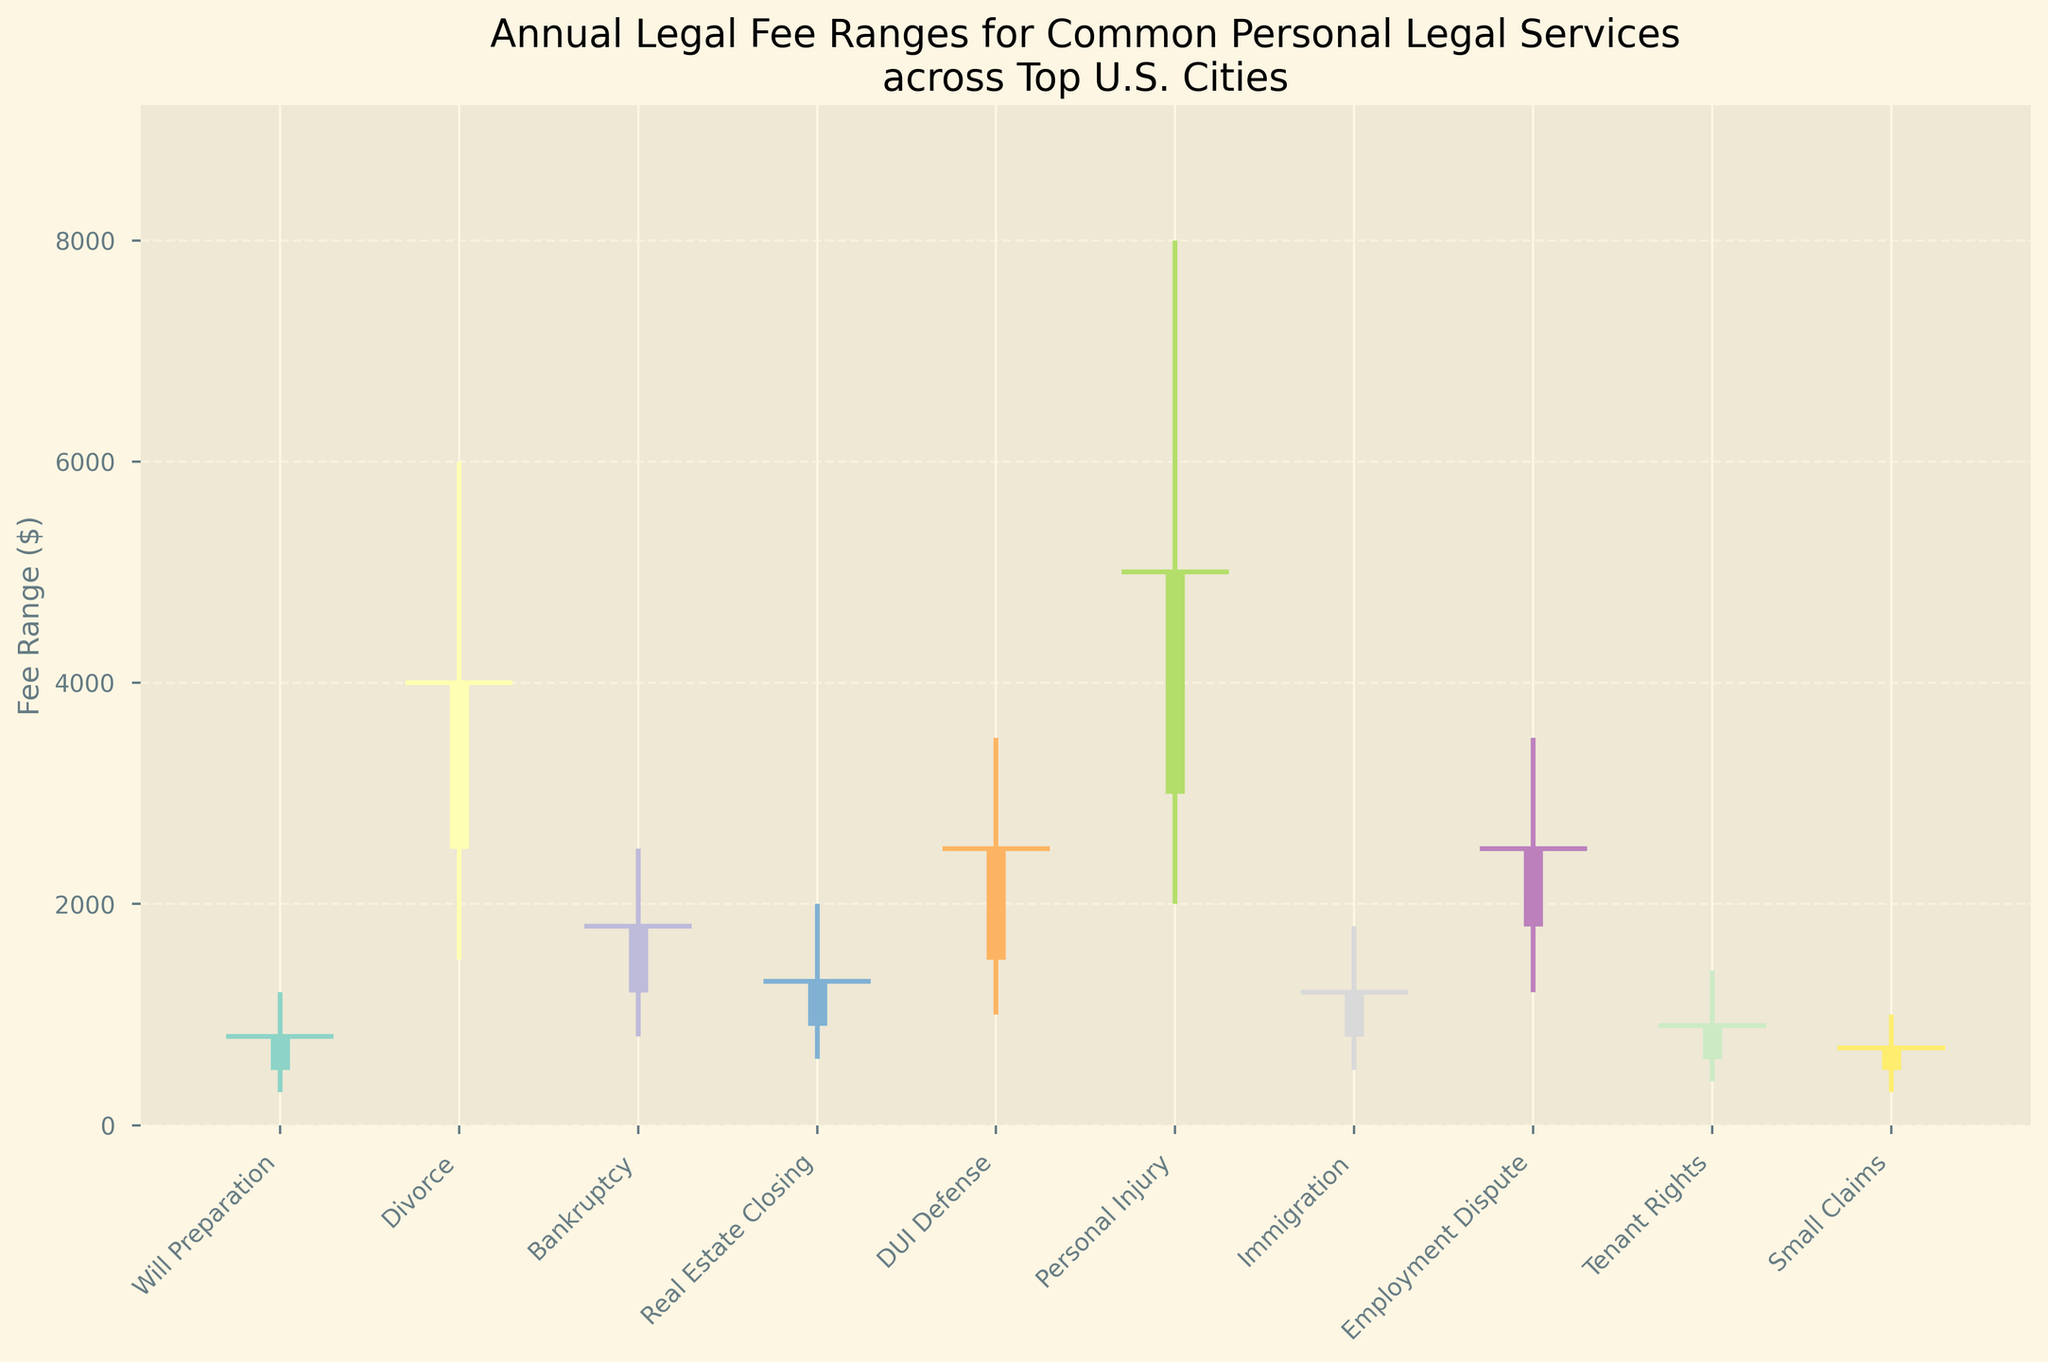What is the title of the chart? The title of the chart is displayed at the top and summarizes what the chart is about
Answer: Annual Legal Fee Ranges for Common Personal Legal Services across Top U.S. Cities Which city has the highest maximum fee for Personal Injury services? By looking at the high values, the highest maximum fee for Personal Injury services is highlighted
Answer: San Francisco What is the fee range for Will Preparation services in New York? The fee range is the difference between the high and low values for Will Preparation services in New York
Answer: $300 to $1200 How does the fee for DUI Defense in Houston compare to Divorce in Los Angeles at the low end? Compare the low values for DUI Defense and Divorce services in the respective cities
Answer: DUI Defense: $1000, Divorce: $1500, so Divorce in Los Angeles is higher Which legal service has the smallest difference between its opening and closing fees in Boston? Calculate the difference between the opening and closing fees for each service in Boston
Answer: Immigration, with fees from $800 to $1200 What is the average fee for Real Estate Closing services in Miami? Average fee can be calculated by (low + high) / 2
Answer: (600 + 2000)/2 = $1300 Which city has the widest fee range for Employment Dispute services? Look for the service "Employment Dispute" and find the city with the largest difference between high and low fees
Answer: Seattle What is the highest closing fee among all the services and cities? Look through the close values to identify the highest
Answer: $5000 for Personal Injury in San Francisco Which service in Denver has its opening fee closer to its high fee than to its low fee? Compare the placement of the opening fee relative to its low and high for services in Denver
Answer: Tenant Rights, with an opening of 600, low of 400, and high of 1400 